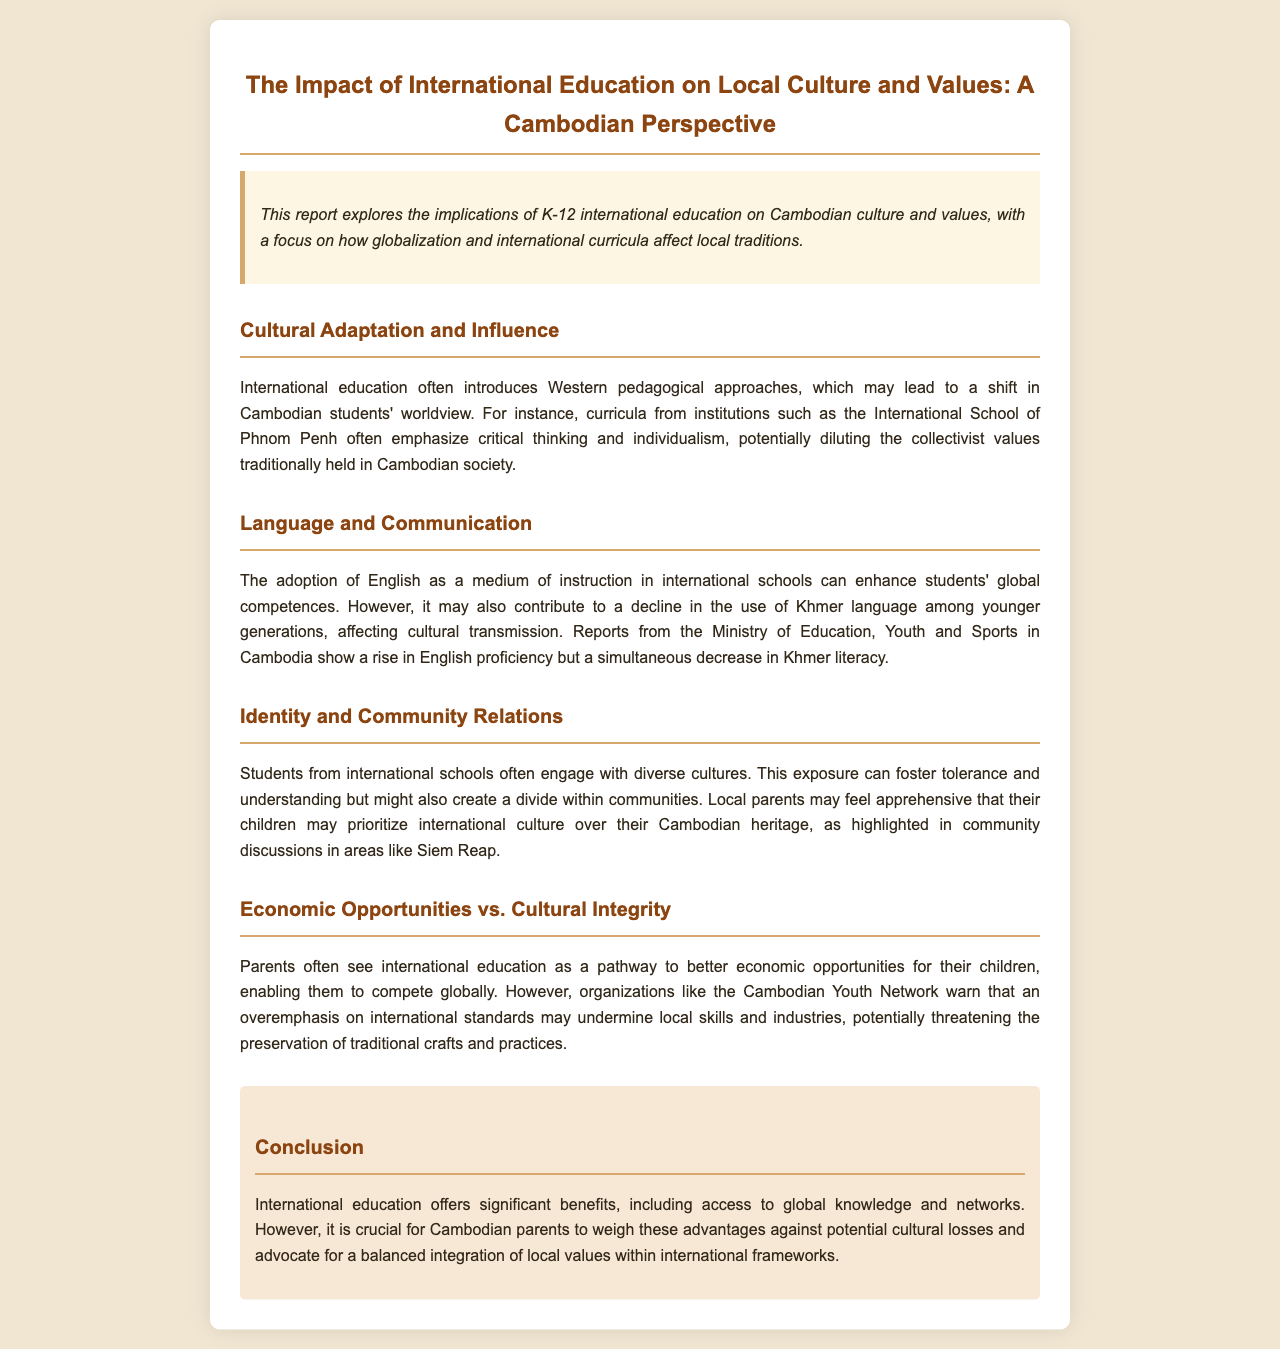What is the primary focus of the report? The report explores the implications of K-12 international education on Cambodian culture and values.
Answer: Implications of K-12 international education What pedagogical approaches are commonly introduced in international education? International education often introduces Western pedagogical approaches.
Answer: Western pedagogical approaches What language is primarily used as a medium of instruction in international schools? The adoption of English as a medium of instruction is highlighted in the report.
Answer: English What significant trend does the Ministry of Education report regarding language? There is a rise in English proficiency alongside a decrease in Khmer literacy.
Answer: Decrease in Khmer literacy Which local area is mentioned in discussions about cultural identity? Community discussions are highlighted in areas like Siem Reap.
Answer: Siem Reap What do parents often see as a benefit of international education? Parents often see economic opportunities as a benefit.
Answer: Economic opportunities What organization warns about a potential cultural threat? The Cambodian Youth Network warns about undermining local skills and industries.
Answer: Cambodian Youth Network What do Cambodian parents need to advocate for according to the conclusion? Parents should advocate for a balanced integration of local values.
Answer: Balanced integration of local values 